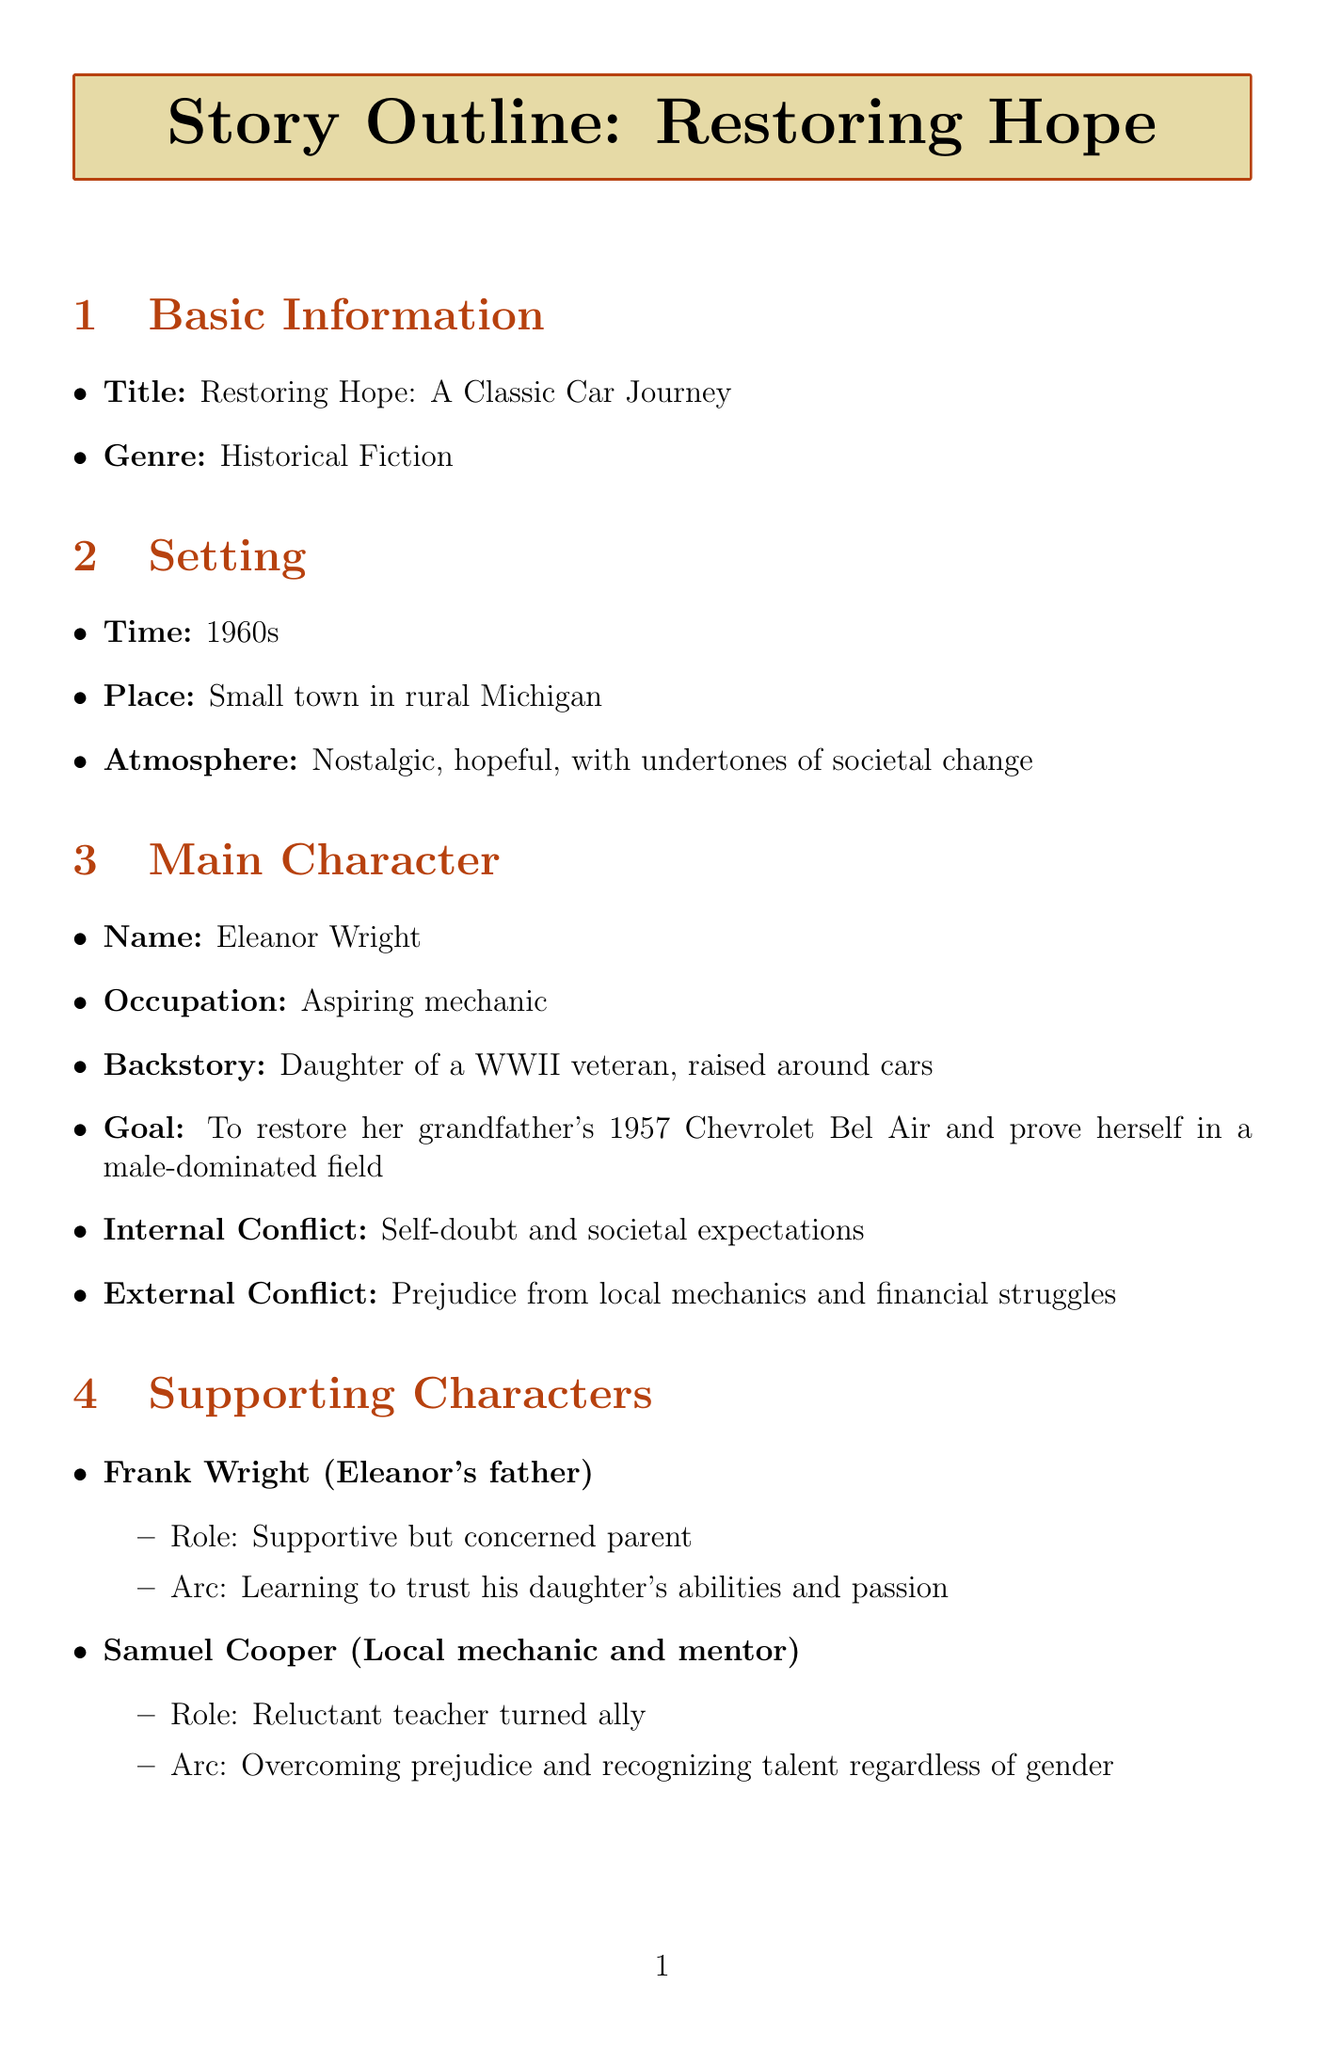What is the title of the story? The title is explicitly mentioned in the document under Basic Information.
Answer: Restoring Hope: A Classic Car Journey Who is the main character? The document states the name of the main character in the Main Character section.
Answer: Eleanor Wright What decade is the story set in? The setting specifies the time period in the Setting section of the document.
Answer: 1960s What is Eleanor's goal? The main character's goal is clearly outlined in the Main Character section.
Answer: To restore her grandfather's 1957 Chevrolet Bel Air and prove herself in a male-dominated field What symbolizes societal prejudices needing to be overcome? The symbolism section describes various symbols related to the story's themes.
Answer: Rust What event is the Climax of the story? The Climax plot point summarizes the peak moment in the narrative as described in the Plot Points section.
Answer: Eleanor's Bel Air faces off against the auto shop owner's prized Thunderbird How does Frank Wright support Eleanor? Frank's role is detailed in the Supporting Characters section, indicating his relationship with Eleanor.
Answer: Supportive but concerned parent What theme relates to gender stereotypes? The document lists multiple themes associated with the story, including one addressing societal issues.
Answer: Breaking gender stereotypes 